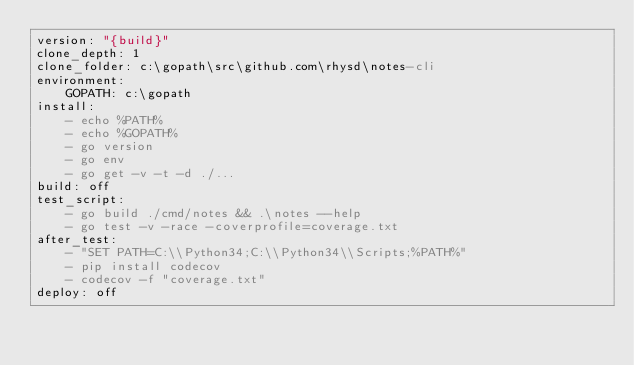Convert code to text. <code><loc_0><loc_0><loc_500><loc_500><_YAML_>version: "{build}"
clone_depth: 1
clone_folder: c:\gopath\src\github.com\rhysd\notes-cli
environment:
    GOPATH: c:\gopath
install:
    - echo %PATH%
    - echo %GOPATH%
    - go version
    - go env
    - go get -v -t -d ./...
build: off
test_script:
    - go build ./cmd/notes && .\notes --help
    - go test -v -race -coverprofile=coverage.txt
after_test:
    - "SET PATH=C:\\Python34;C:\\Python34\\Scripts;%PATH%"
    - pip install codecov
    - codecov -f "coverage.txt"
deploy: off
</code> 